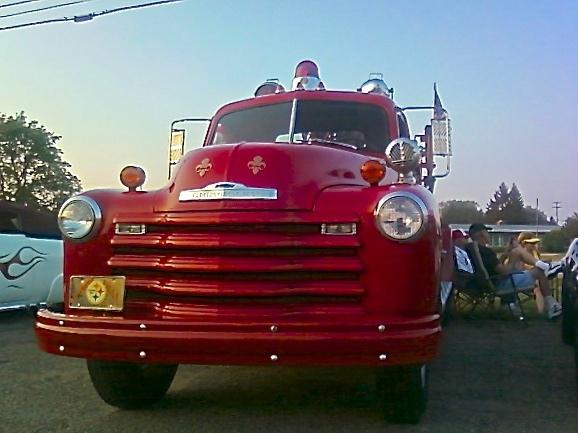What do those riding this vessel use to do their jobs? water 